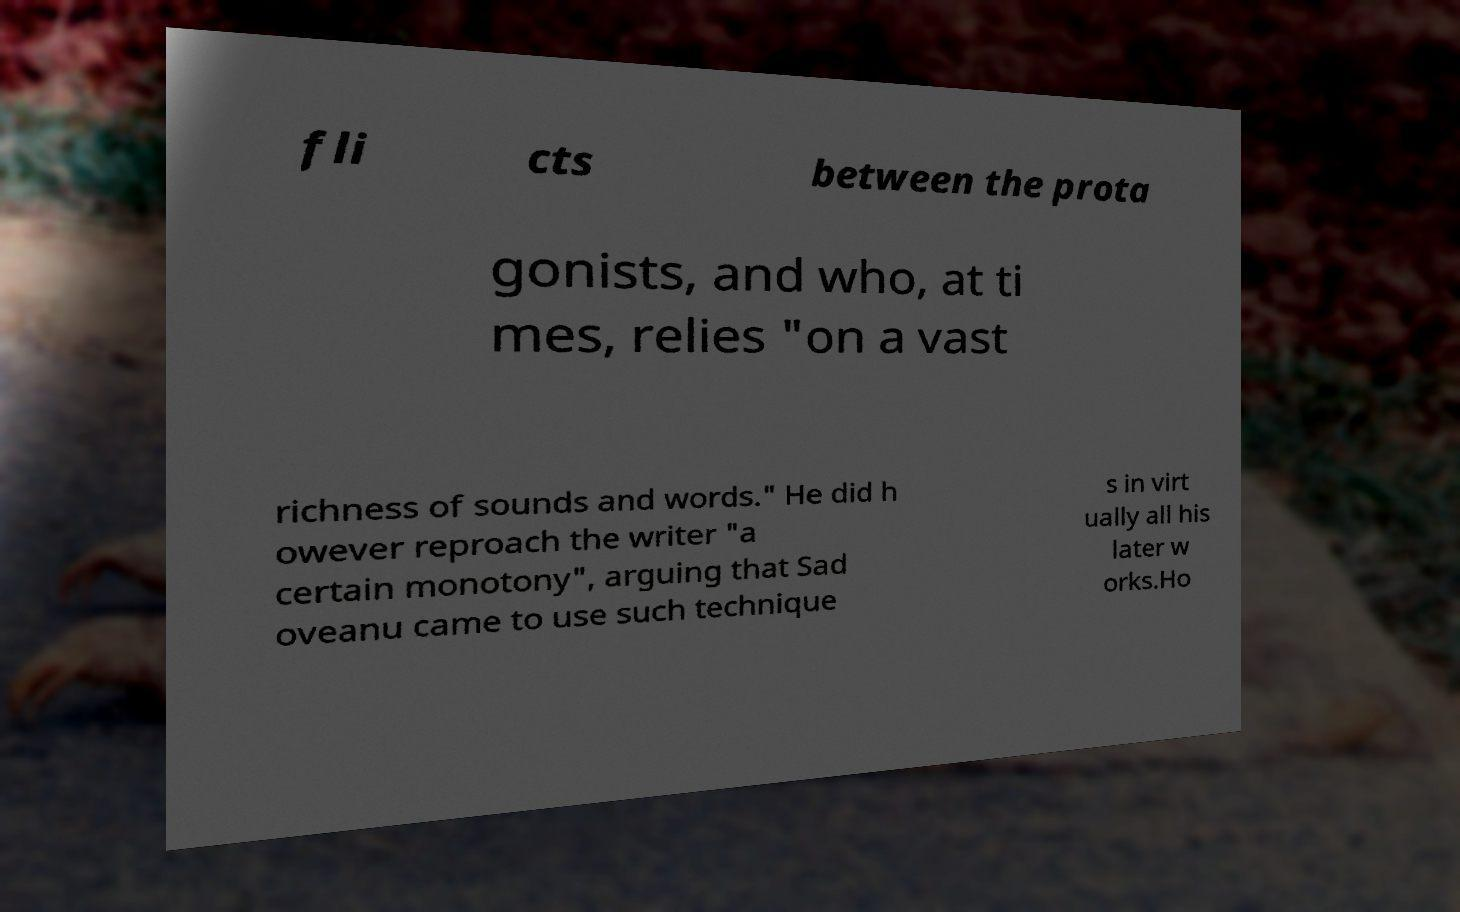Could you extract and type out the text from this image? fli cts between the prota gonists, and who, at ti mes, relies "on a vast richness of sounds and words." He did h owever reproach the writer "a certain monotony", arguing that Sad oveanu came to use such technique s in virt ually all his later w orks.Ho 